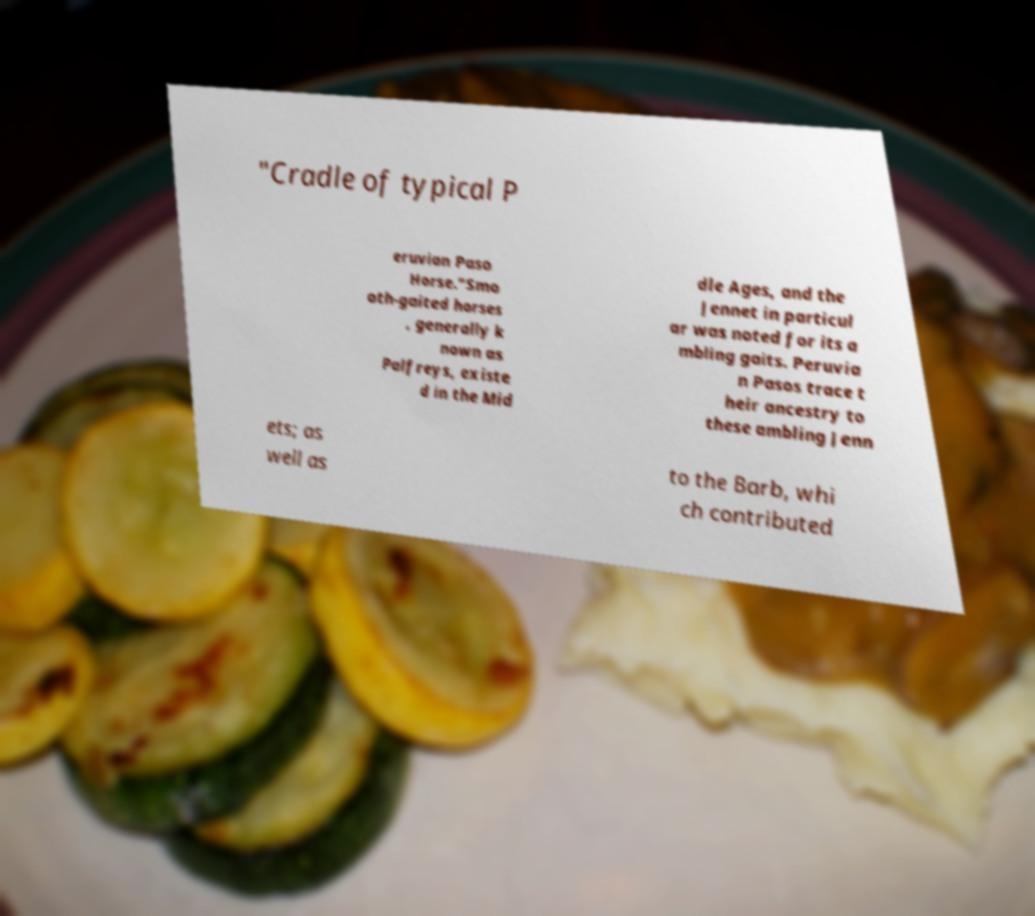I need the written content from this picture converted into text. Can you do that? "Cradle of typical P eruvian Paso Horse."Smo oth-gaited horses , generally k nown as Palfreys, existe d in the Mid dle Ages, and the Jennet in particul ar was noted for its a mbling gaits. Peruvia n Pasos trace t heir ancestry to these ambling Jenn ets; as well as to the Barb, whi ch contributed 